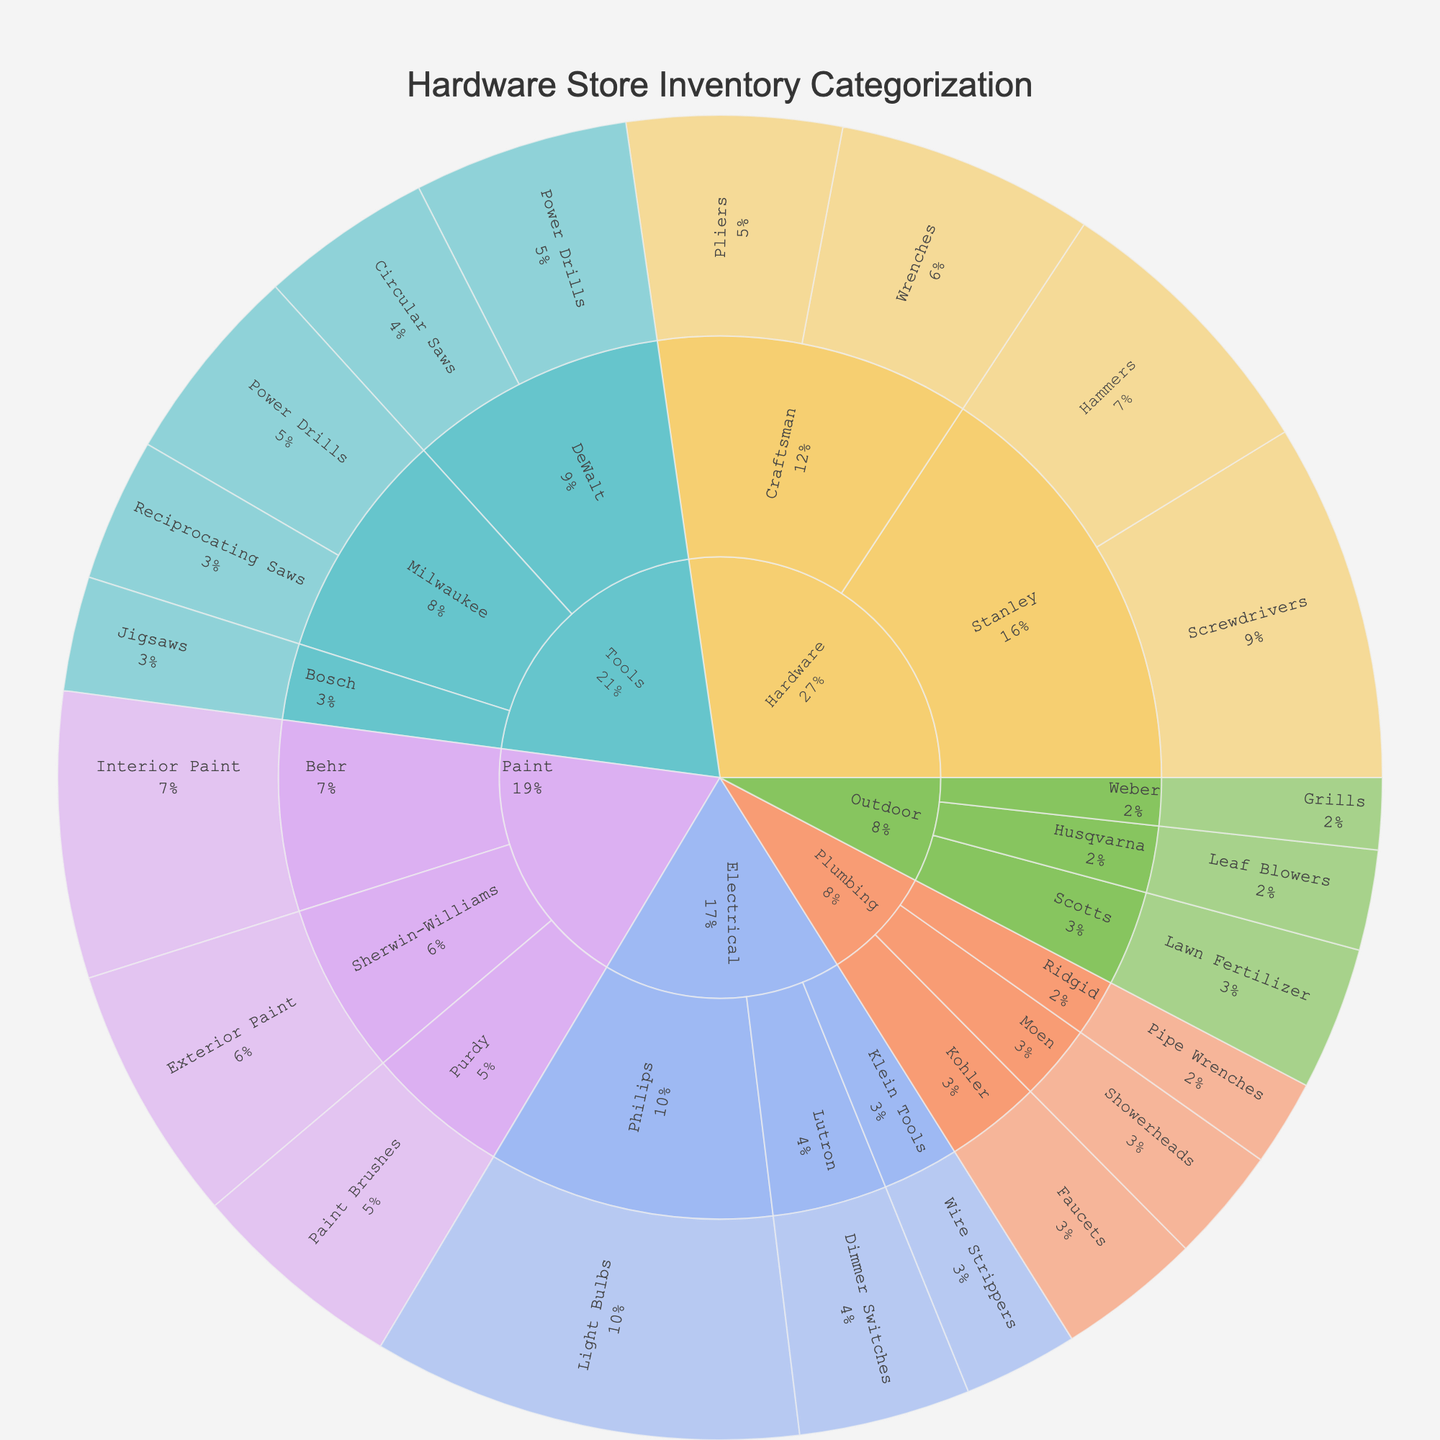How many departments are displayed in the sunburst plot? The plot uses different colors for each department and they are organized as the first level in the hierarchy. You can count them visually.
Answer: 5 Which brand has the highest number of hammers? Navigate to the "Hardware" department, look at the brands, and find the "Stanley" brand and its value under "Hammers".
Answer: Stanley What's the total value of products in the "Tools" department? Sum the values of each product under the "Tools" department node by looking at the values of "Power Drills", "Circular Saws", "Reciprocating Saws", and "Jigsaws": 15 + 12 + 14 + 10 + 8.
Answer: 59 Which department has the highest total inventory value? Compare the summed values of each department's products. "Electrical" has a significant amount of 30, 12, and 8: 30 + 12 + 8 = 50.
Answer: Electrical In the Plumbing department, which product type has the lowest value? Examine the product types under the "Plumbing" department node and compare their values. "Pipe Wrenches" by Ridgid has the value of 6, which is the lowest.
Answer: Pipe Wrenches How many brands are listed within the Hardware department? Each segment within the "Hardware" node represents a different brand. Count these segments. There should be "Stanley" and "Craftsman".
Answer: 2 What's the combined value of "Light Bulbs" and "Dimmer Switches" in the Electrical department? Look at the values for "Light Bulbs" and "Dimmer Switches" under the "Electrical" department: 30 + 12.
Answer: 42 Are there more "Interior Paint" or "Exterior Paint" products? Compare the values of "Interior Paint" and "Exterior Paint" under the "Paint" department: 20 (Interior) vs. 18 (Exterior).
Answer: Interior Paint What percentage of the total Tools inventory is made up by DeWalt's products? First, sum up the values of DeWalt's products: 15 (Power Drills) + 12 (Circular Saws) = 27. Then, calculate the percentage of DeWalt's products out of the total Tools value: 27 / 59 ≈ 45.8%.
Answer: ~45.8% Which product has the lowest value in the entire inventory? Navigate through the departments and look for the smallest value. "Grills" by Weber in the "Outdoor" department has a value of 5, which is the lowest.
Answer: Grills 